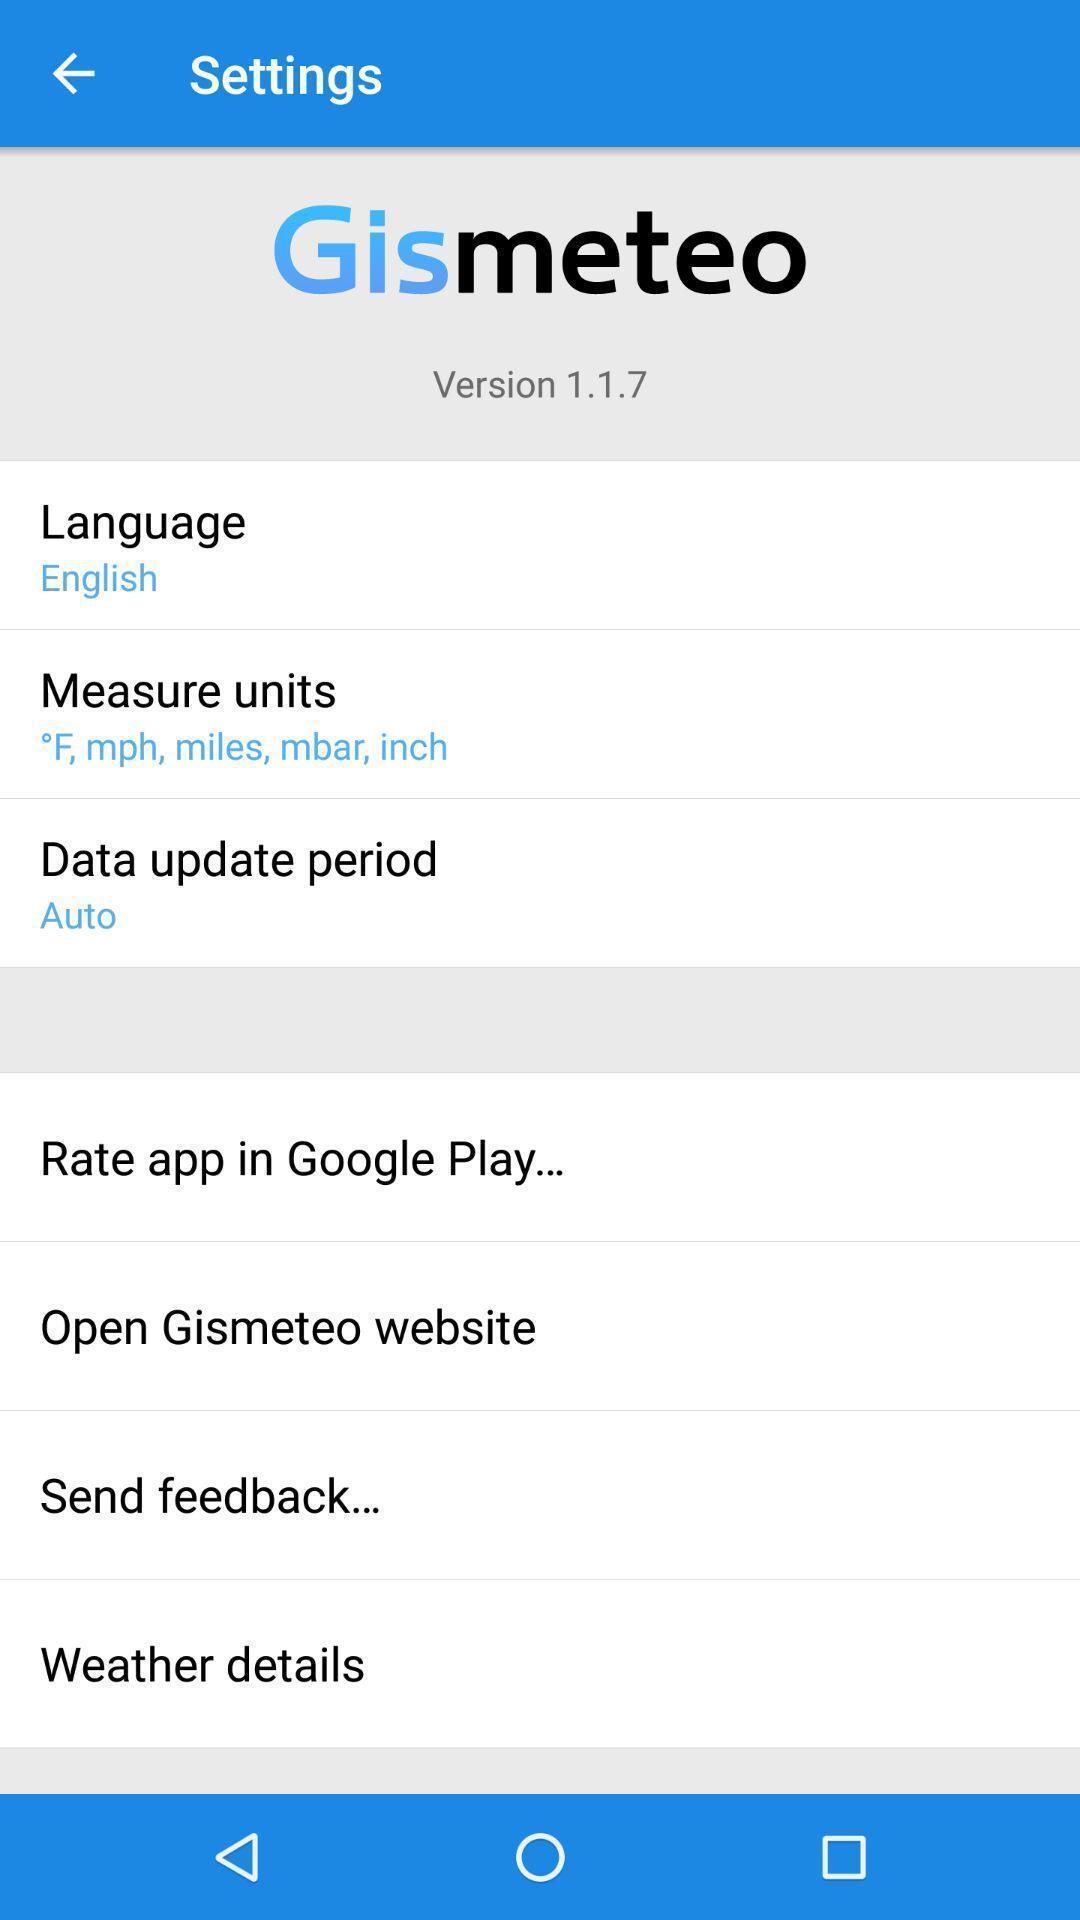Describe the key features of this screenshot. Screen showing settings page. 